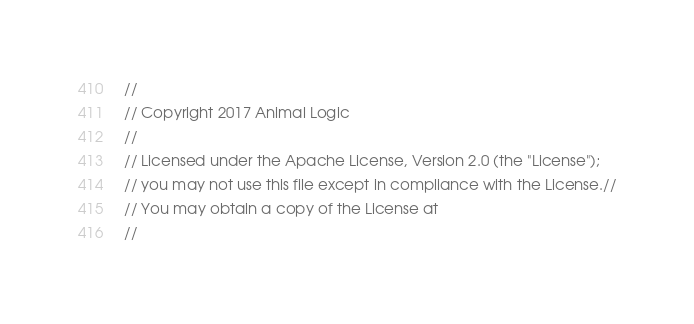<code> <loc_0><loc_0><loc_500><loc_500><_C++_>//
// Copyright 2017 Animal Logic
//
// Licensed under the Apache License, Version 2.0 (the "License");
// you may not use this file except in compliance with the License.//
// You may obtain a copy of the License at
//</code> 